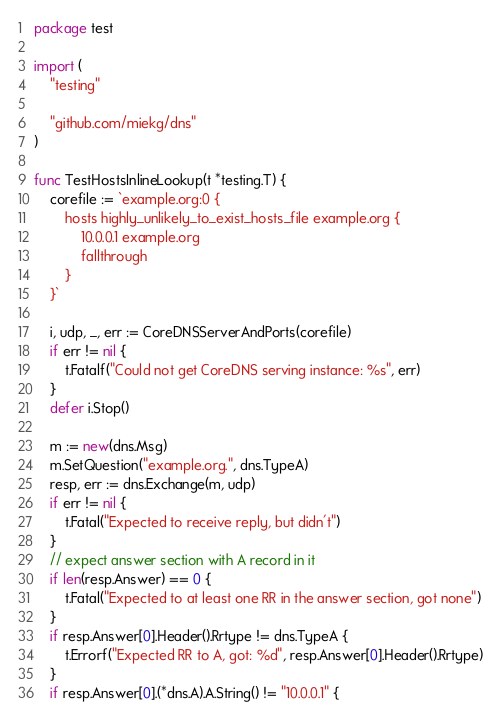<code> <loc_0><loc_0><loc_500><loc_500><_Go_>package test

import (
	"testing"

	"github.com/miekg/dns"
)

func TestHostsInlineLookup(t *testing.T) {
	corefile := `example.org:0 {
		hosts highly_unlikely_to_exist_hosts_file example.org {
			10.0.0.1 example.org
			fallthrough
		}
	}`

	i, udp, _, err := CoreDNSServerAndPorts(corefile)
	if err != nil {
		t.Fatalf("Could not get CoreDNS serving instance: %s", err)
	}
	defer i.Stop()

	m := new(dns.Msg)
	m.SetQuestion("example.org.", dns.TypeA)
	resp, err := dns.Exchange(m, udp)
	if err != nil {
		t.Fatal("Expected to receive reply, but didn't")
	}
	// expect answer section with A record in it
	if len(resp.Answer) == 0 {
		t.Fatal("Expected to at least one RR in the answer section, got none")
	}
	if resp.Answer[0].Header().Rrtype != dns.TypeA {
		t.Errorf("Expected RR to A, got: %d", resp.Answer[0].Header().Rrtype)
	}
	if resp.Answer[0].(*dns.A).A.String() != "10.0.0.1" {</code> 